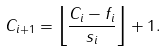Convert formula to latex. <formula><loc_0><loc_0><loc_500><loc_500>C _ { i + 1 } = \left \lfloor \frac { C _ { i } - f _ { i } } { s _ { i } } \right \rfloor + 1 .</formula> 